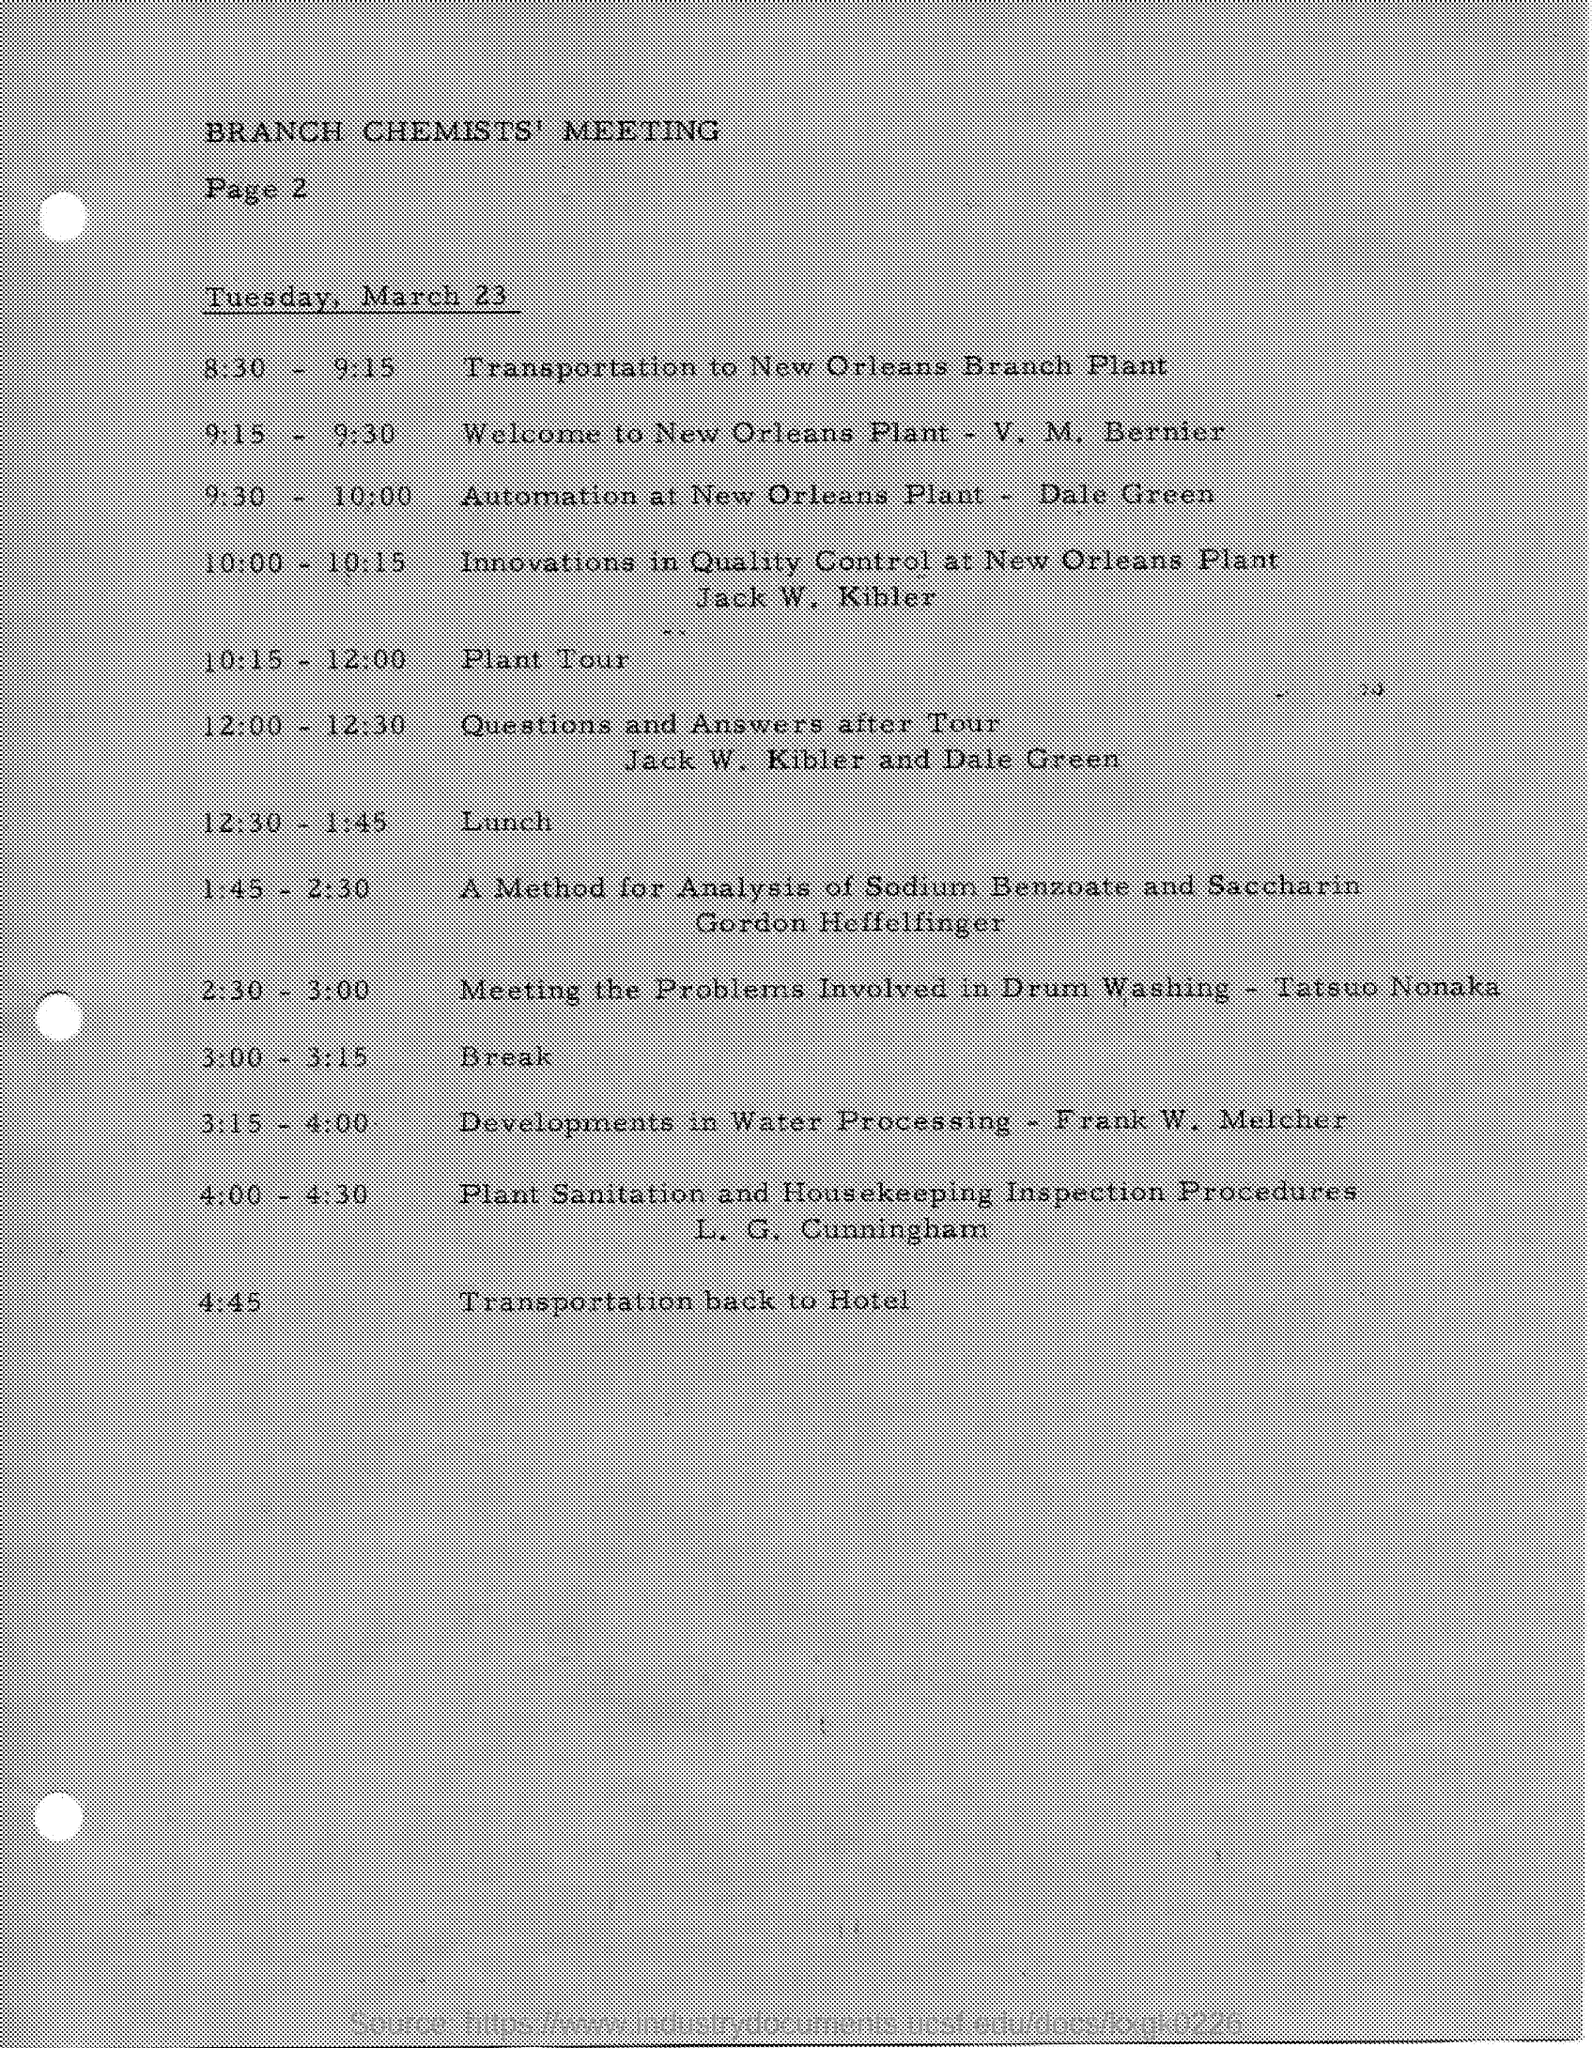Identify some key points in this picture. The date mentioned is Tuesday, March 23. Lunch time is from 12:30 PM to 1:45 PM. The Branch Chemists Meeting is mentioned in the text. 